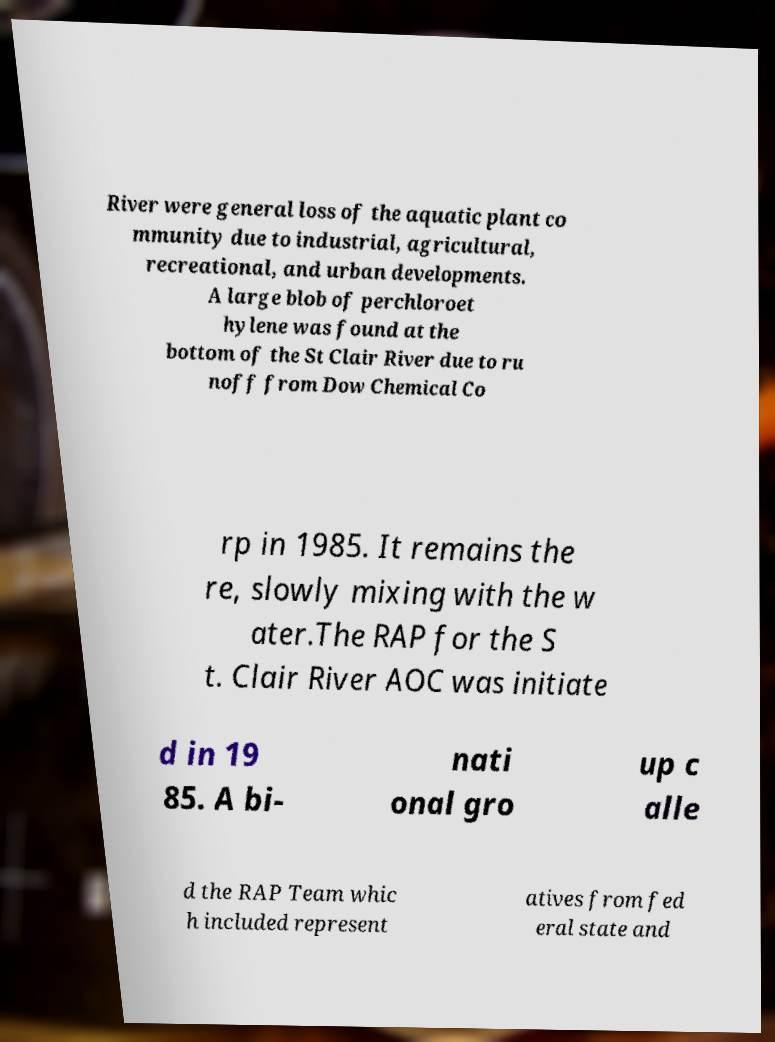Can you read and provide the text displayed in the image?This photo seems to have some interesting text. Can you extract and type it out for me? River were general loss of the aquatic plant co mmunity due to industrial, agricultural, recreational, and urban developments. A large blob of perchloroet hylene was found at the bottom of the St Clair River due to ru noff from Dow Chemical Co rp in 1985. It remains the re, slowly mixing with the w ater.The RAP for the S t. Clair River AOC was initiate d in 19 85. A bi- nati onal gro up c alle d the RAP Team whic h included represent atives from fed eral state and 